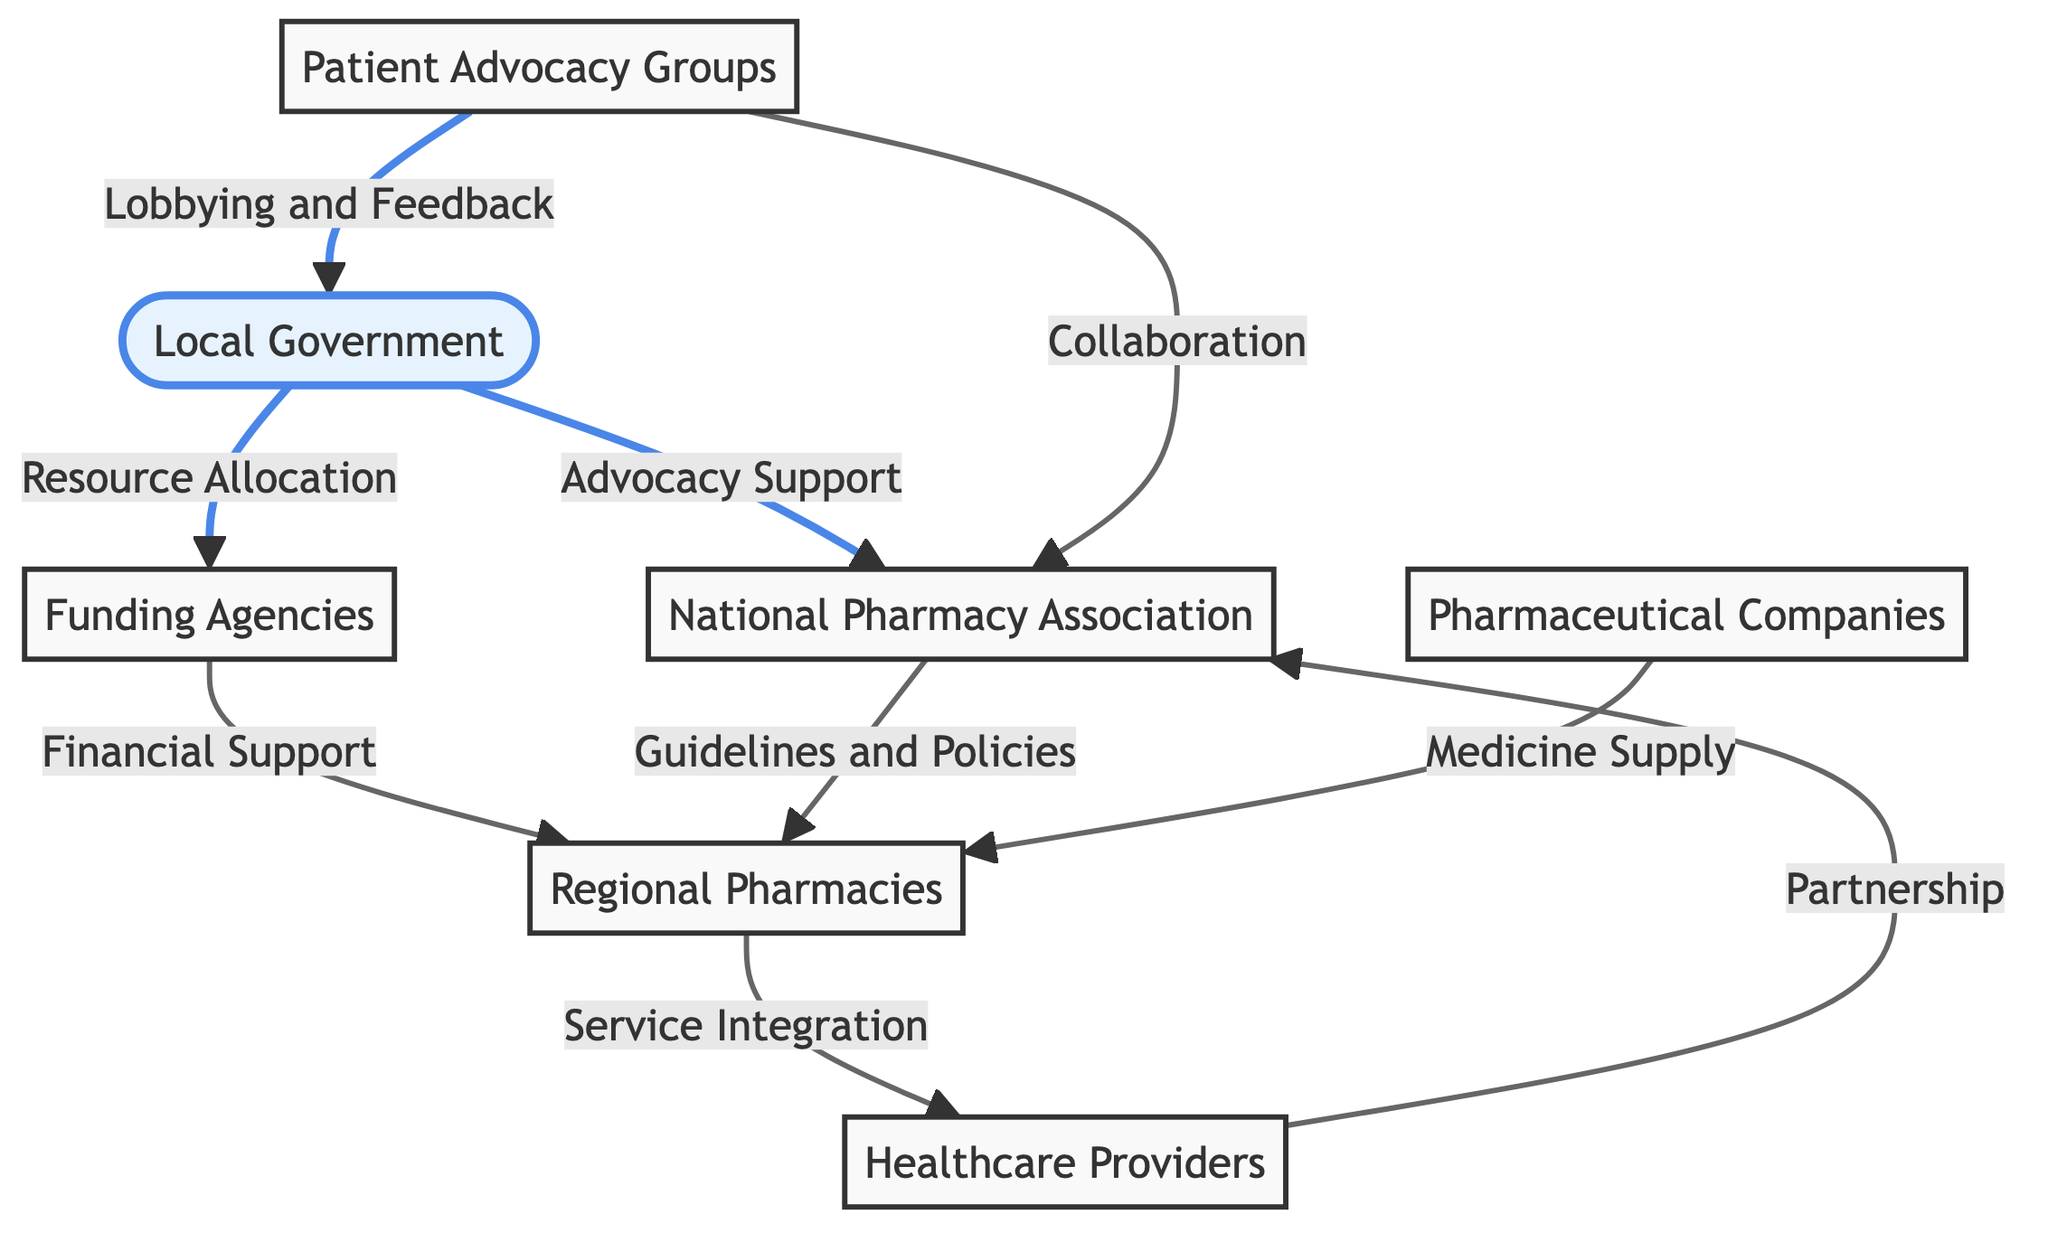What is the total number of nodes in the diagram? The diagram lists seven distinct nodes: Local Government, National Pharmacy Association, Regional Pharmacies, Healthcare Providers, Funding Agencies, Pharmaceutical Companies, and Patient Advocacy Groups. Counting these gives a total of 7 nodes.
Answer: 7 Which node provides financial support to Regional Pharmacies? The edge labeled "Financial Support" connects Funding Agencies to Regional Pharmacies, indicating that Funding Agencies are responsible for providing financial support to them.
Answer: Funding Agencies What type of relationship exists between Local Government and Pharmacy Association? The connection labeled "Advocacy Support" shows that Local Government has a supportive role in advocating for the Pharmacy Association, defining this relationship as one of advocacy and support.
Answer: Advocacy Support How many connections are there from Patient Advocacy Groups? Examining the diagram reveals that Patient Advocacy Groups have two outgoing connections: one to Local Government and another to Pharmacy Association. Thus, they have a total of 2 connections.
Answer: 2 Which entity is involved in both collaboration and lobbying? Patient Advocacy Groups are depicted in the diagram as involved in collaboration (with Pharmacy Association) and lobbying (with Local Government), making them the entity engaged in both actions.
Answer: Patient Advocacy Groups What do Regional Pharmacies integrate services with? The diagram indicates that Regional Pharmacies have a connection labeled "Service Integration" leading to Healthcare Providers, signifying that they integrate services with Healthcare Providers.
Answer: Healthcare Providers How many edges connect the Local Government to other nodes? Reviewing the diagram, Local Government has two outgoing edges: one to Pharmacy Association (Advocacy Support) and another to Funding Agencies (Resource Allocation), resulting in a total of 2 connections.
Answer: 2 Which organization provides guidelines and policies to Regional Pharmacies? The edge labeled "Guidelines and Policies" connects Pharmacy Association to Regional Pharmacies, clarifying that Pharmacy Association is the organization providing these guidelines and policies.
Answer: Pharmacy Association What is the connection type between Healthcare Providers and Pharmacy Association? The diagram shows that Healthcare Providers connect to Pharmacy Association with a relationship labeled "Partnership," defining the nature of their interaction as a partnership.
Answer: Partnership 